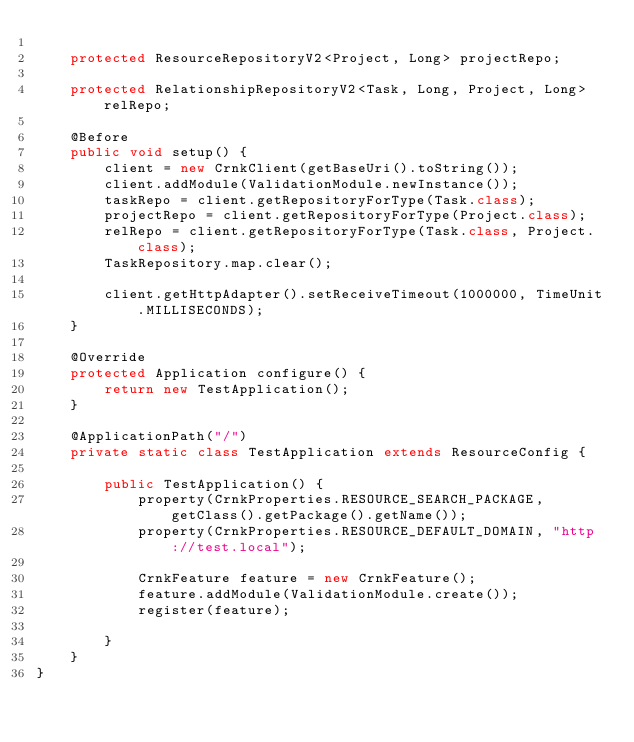Convert code to text. <code><loc_0><loc_0><loc_500><loc_500><_Java_>
	protected ResourceRepositoryV2<Project, Long> projectRepo;

	protected RelationshipRepositoryV2<Task, Long, Project, Long> relRepo;

	@Before
	public void setup() {
		client = new CrnkClient(getBaseUri().toString());
		client.addModule(ValidationModule.newInstance());
		taskRepo = client.getRepositoryForType(Task.class);
		projectRepo = client.getRepositoryForType(Project.class);
		relRepo = client.getRepositoryForType(Task.class, Project.class);
		TaskRepository.map.clear();

		client.getHttpAdapter().setReceiveTimeout(1000000, TimeUnit.MILLISECONDS);
	}

	@Override
	protected Application configure() {
		return new TestApplication();
	}

	@ApplicationPath("/")
	private static class TestApplication extends ResourceConfig {

		public TestApplication() {
			property(CrnkProperties.RESOURCE_SEARCH_PACKAGE, getClass().getPackage().getName());
			property(CrnkProperties.RESOURCE_DEFAULT_DOMAIN, "http://test.local");

			CrnkFeature feature = new CrnkFeature();
			feature.addModule(ValidationModule.create());
			register(feature);

		}
	}
}
</code> 